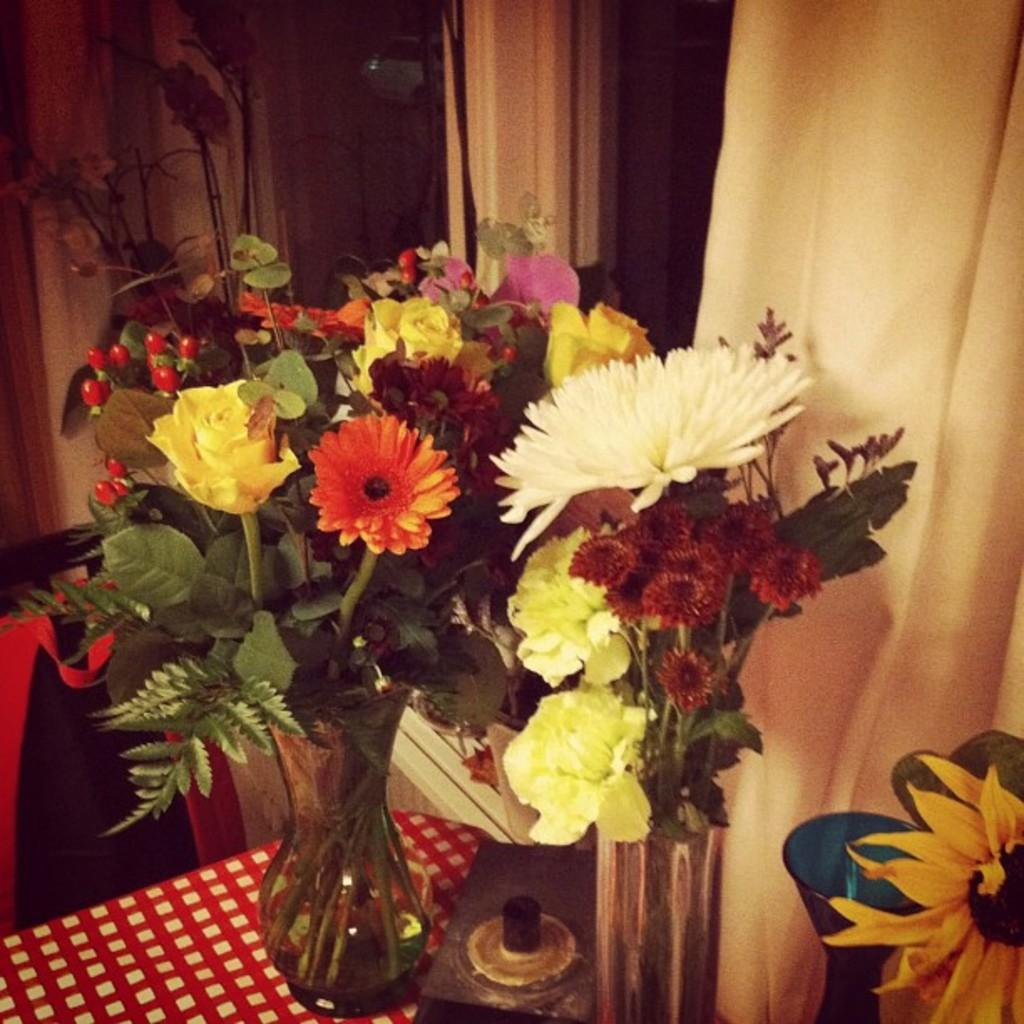What type of objects can be seen in the image? There are flower vases in the image. Can you describe the object in the image? There is an object in the image, but its specific details are not mentioned in the facts. What is the color scheme of the surface in the image? The surface in the image is red and white. What can be seen in the background of the image? There is a glass window and curtains in the background of the image. What type of suit is the person wearing in the image? There is no person or suit present in the image; it features flower vases, an object, and a red and white surface. What impulse caused the object to be placed in the image? The facts do not provide any information about the reason or impulse behind placing the object in the image. 